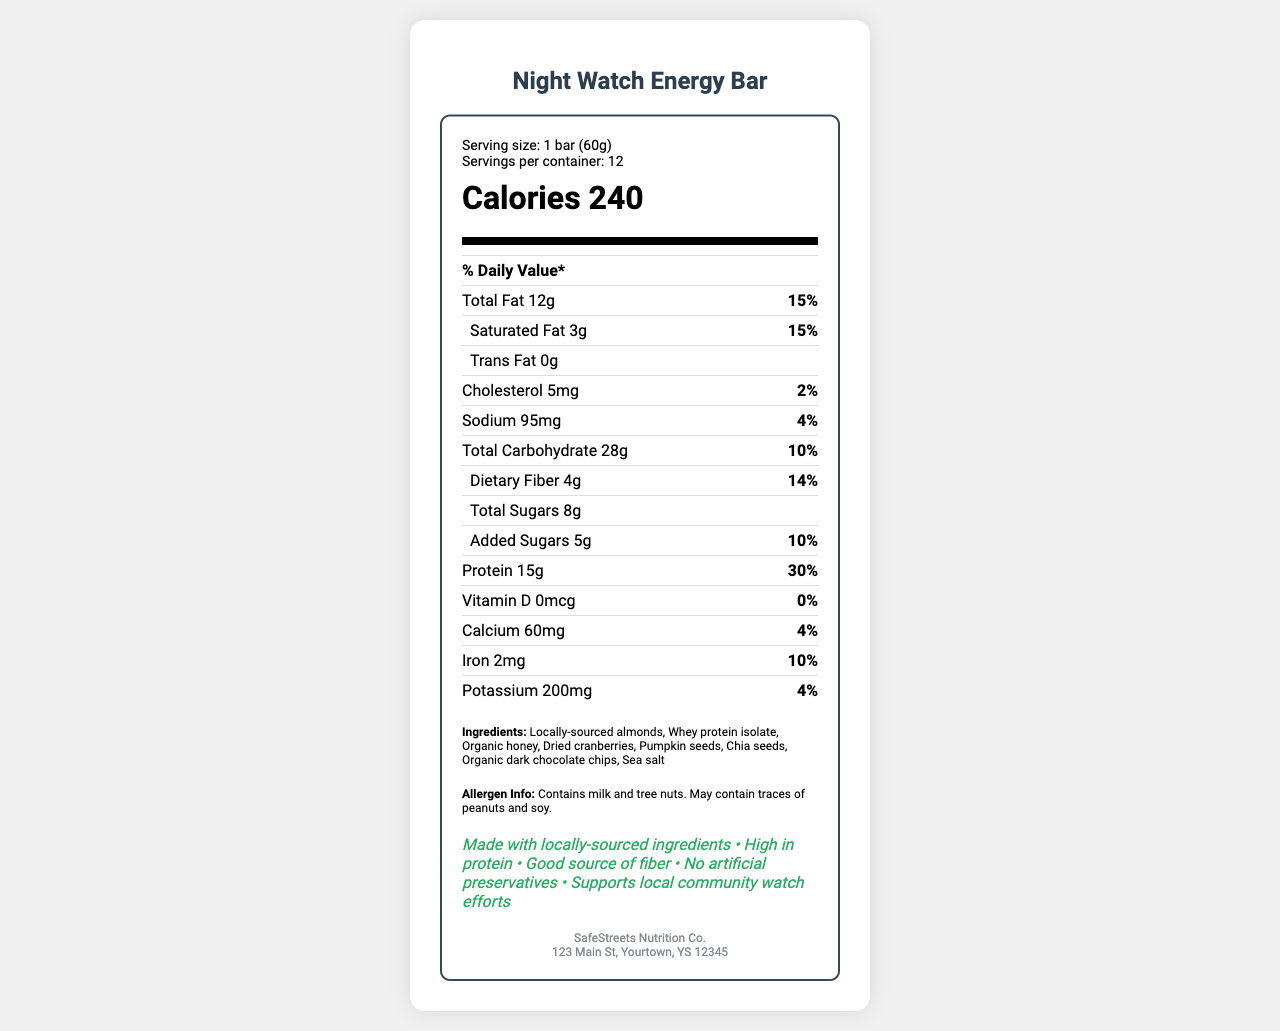what is the serving size of the Night Watch Energy Bar? The serving size of the Night Watch Energy Bar is clearly mentioned as "1 bar (60g)" in the document.
Answer: 1 bar (60g) how many calories are in one serving? The document lists the number of calories per serving as 240.
Answer: 240 what percentage of the daily recommended protein intake is provided by one bar? According to the document, one bar provides 30% of the daily recommended protein intake.
Answer: 30% which ingredients are listed in the document? The ingredients are listed as "Locally-sourced almonds, Whey protein isolate, Organic honey, Dried cranberries, Pumpkin seeds, Chia seeds, Organic dark chocolate chips, Sea salt."
Answer: Locally-sourced almonds, Whey protein isolate, Organic honey, Dried cranberries, Pumpkin seeds, Chia seeds, Organic dark chocolate chips, Sea salt what is the total amount of fat in each bar? The document states that each bar contains 12g of total fat.
Answer: 12g how much saturated fat is there in one serving? Saturated fat content per serving is mentioned as 3g.
Answer: 3g what types of allergens are present in the bar? The allergen information specifies that the bar contains milk and tree nuts and may contain traces of peanuts and soy.
Answer: Contains milk and tree nuts. May contain traces of peanuts and soy. how many milligrams of sodium does one bar have? The document provides the sodium amount as 95mg per bar.
Answer: 95mg how many servings are there per container? There are 12 servings per container as mentioned in the document.
Answer: 12 how many grams of dietary fiber are in each bar? Each bar contains 4g of dietary fiber as per the document.
Answer: 4g what is the amount of calcium provided by one bar? The document mentions that one bar provides 60mg of calcium.
Answer: 60mg what are the product claims mentioned in the document?
    A. Contains artificial preservatives
    B. Made with locally-sourced ingredients
    C. High in sugar content
    D. High in protein The product claims mentioned in the document are "Made with locally-sourced ingredients" and "High in protein."
Answer: B and D which nutrient has the highest daily value percentage in one serving?
    I. Protein
    II. Calcium
    III. Sodium
    IV. Iron The document states that protein has the highest daily value percentage at 30%.
Answer: I. Protein is the energy bar a good source of Vitamin D? The document indicates that the energy bar contains 0mcg of Vitamin D, which is 0% of the daily value.
Answer: No describe the main idea of the document The document gives comprehensive nutritional facts for the Night Watch Energy Bar, showcasing its health benefits and claims, along with ingredient and allergen details.
Answer: The document provides detailed nutritional information about the Night Watch Energy Bar, including its serving size, calorie content, macronutrient breakdown, vitamins, and minerals. It highlights the use of locally-sourced ingredients, health claims like high protein, and allergen information. It also supports community watch efforts. what is the street address of SafeStreets Nutrition Co.? The manufacturer's address provided in the document is "123 Main St, Yourtown, YS 12345."
Answer: 123 Main St, Yourtown, YS 12345 what is the flavor of the energy bar? The document does not specify the flavor of the energy bar, so the exact flavor cannot be determined from the given information.
Answer: Not enough information 